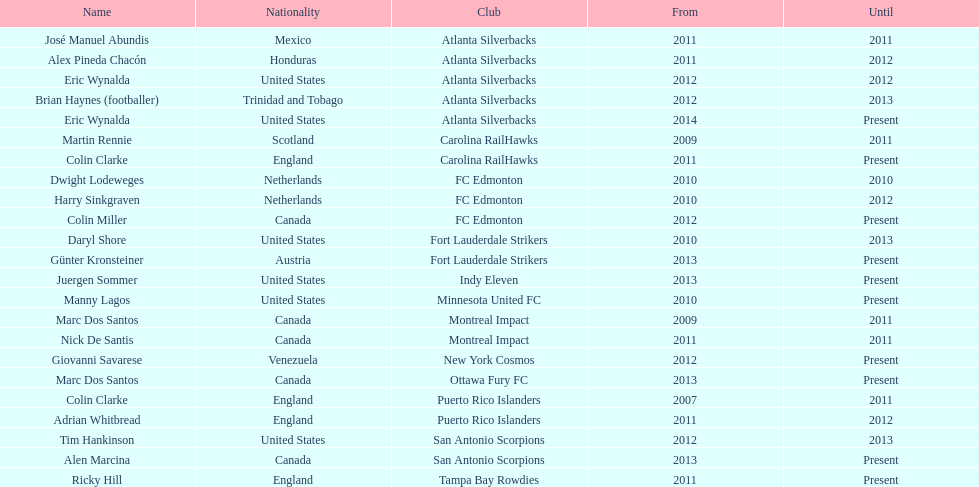Who coached the silverbacks longer, abundis or chacon? Chacon. 